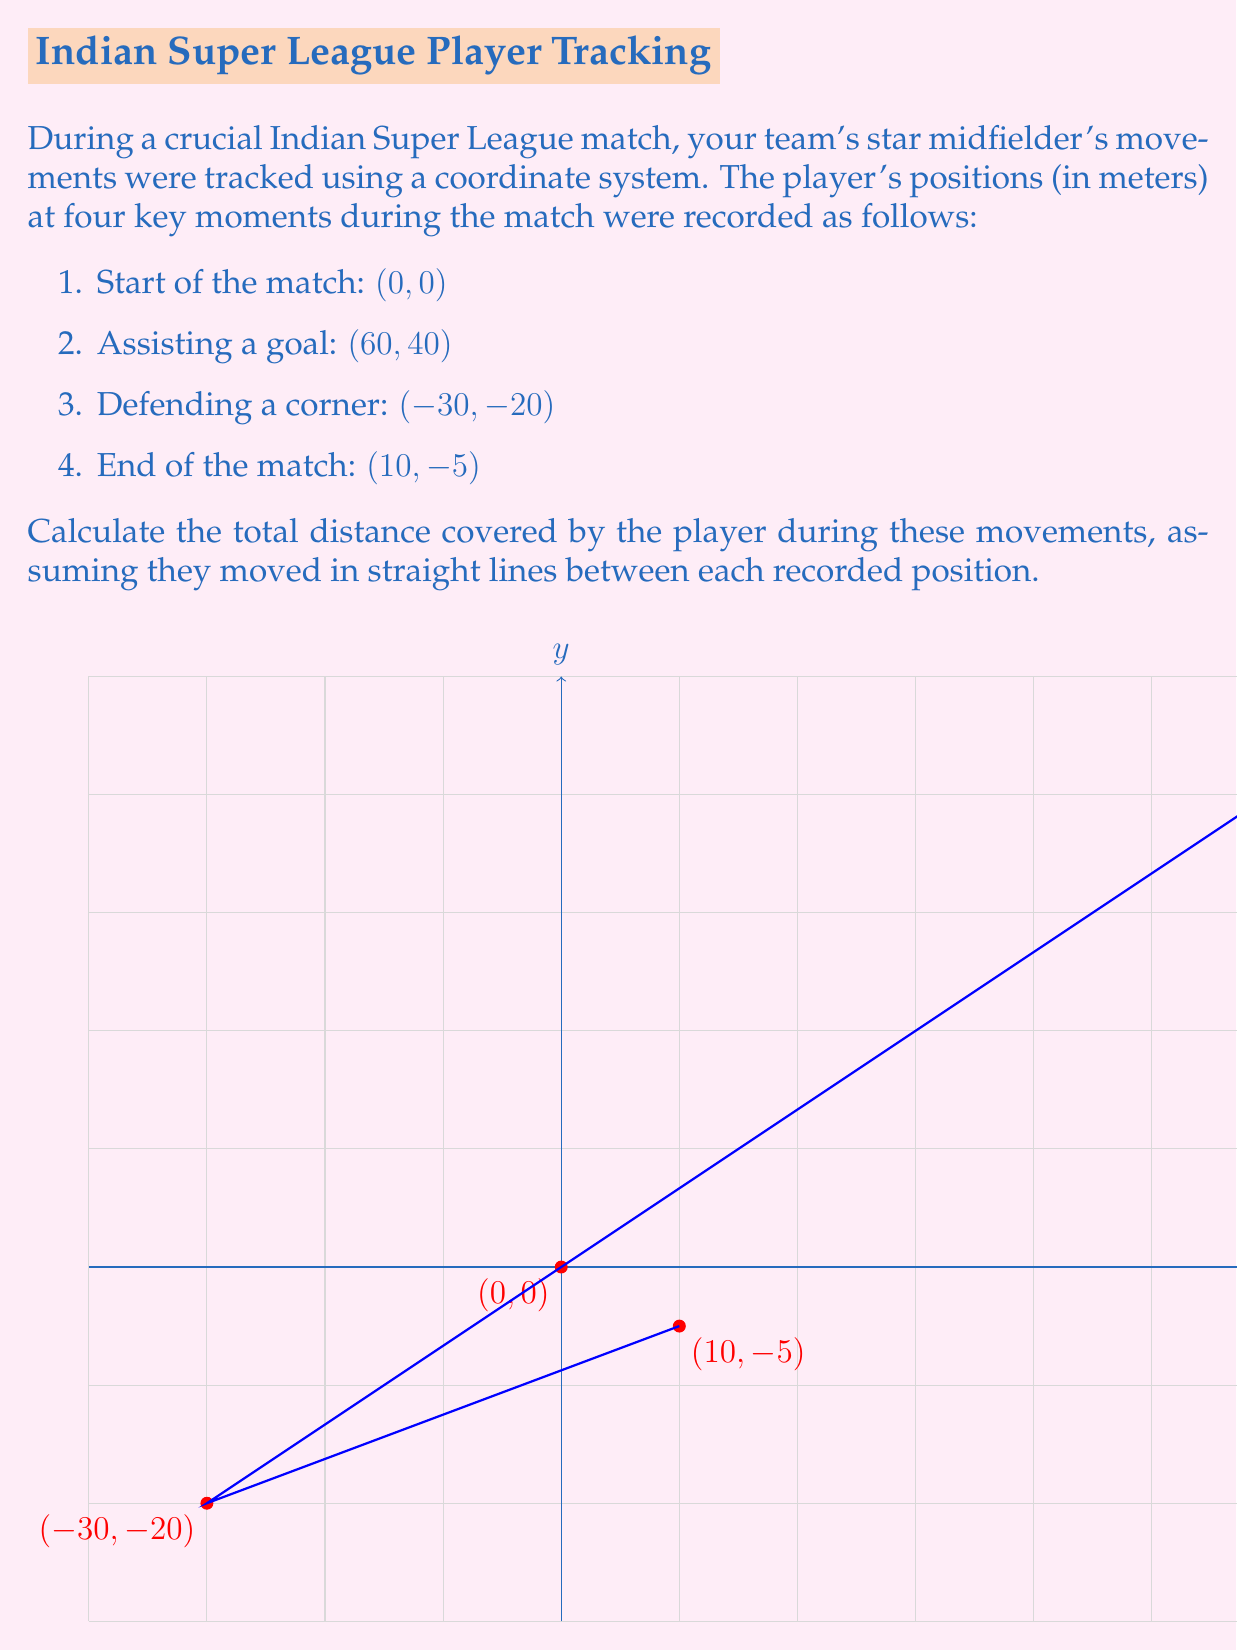Give your solution to this math problem. To solve this problem, we need to calculate the distance between each consecutive pair of points and sum these distances. We can use the distance formula between two points $(x_1, y_1)$ and $(x_2, y_2)$:

$$d = \sqrt{(x_2 - x_1)^2 + (y_2 - y_1)^2}$$

Let's calculate each segment:

1. From (0, 0) to (60, 40):
   $$d_1 = \sqrt{(60 - 0)^2 + (40 - 0)^2} = \sqrt{3600 + 1600} = \sqrt{5200} = 20\sqrt{13} \approx 72.11 \text{ m}$$

2. From (60, 40) to (-30, -20):
   $$d_2 = \sqrt{(-30 - 60)^2 + (-20 - 40)^2} = \sqrt{8100 + 3600} = \sqrt{11700} = 30\sqrt{13} \approx 108.17 \text{ m}$$

3. From (-30, -20) to (10, -5):
   $$d_3 = \sqrt{(10 - (-30))^2 + (-5 - (-20))^2} = \sqrt{1600 + 225} = \sqrt{1825} = 5\sqrt{73} \approx 42.72 \text{ m}$$

Now, we sum these distances:

$$\text{Total distance} = d_1 + d_2 + d_3 = 20\sqrt{13} + 30\sqrt{13} + 5\sqrt{73}$$

$$= 50\sqrt{13} + 5\sqrt{73} \approx 222.99 \text{ m}$$
Answer: $50\sqrt{13} + 5\sqrt{73}$ meters 